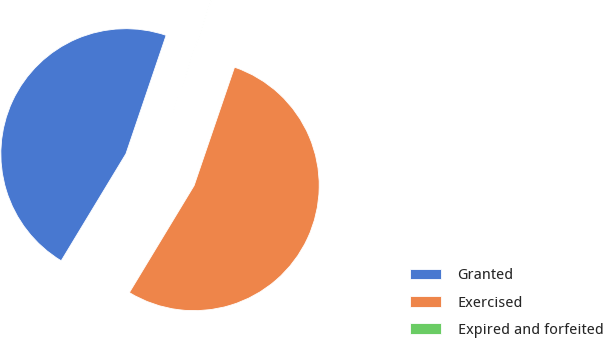Convert chart to OTSL. <chart><loc_0><loc_0><loc_500><loc_500><pie_chart><fcel>Granted<fcel>Exercised<fcel>Expired and forfeited<nl><fcel>46.54%<fcel>53.42%<fcel>0.03%<nl></chart> 